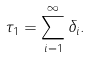Convert formula to latex. <formula><loc_0><loc_0><loc_500><loc_500>\tau _ { 1 } = \sum _ { i = 1 } ^ { \infty } \delta _ { i } .</formula> 